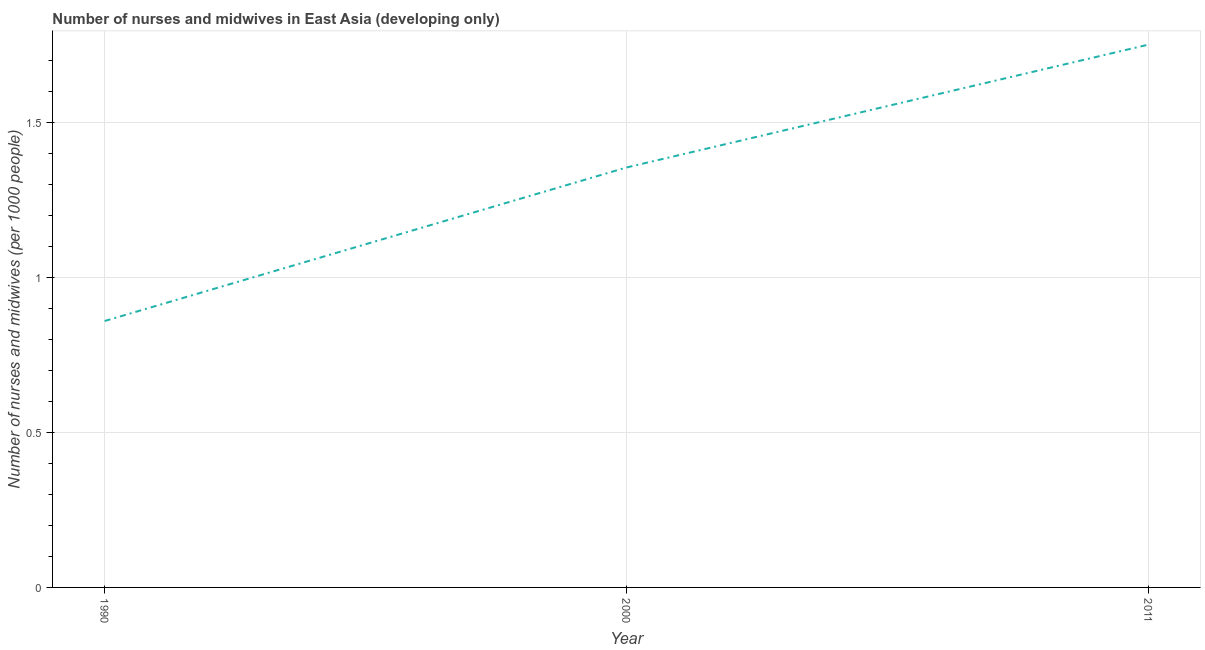What is the number of nurses and midwives in 2011?
Offer a very short reply. 1.75. Across all years, what is the maximum number of nurses and midwives?
Ensure brevity in your answer.  1.75. Across all years, what is the minimum number of nurses and midwives?
Give a very brief answer. 0.86. In which year was the number of nurses and midwives maximum?
Your answer should be compact. 2011. What is the sum of the number of nurses and midwives?
Make the answer very short. 3.97. What is the difference between the number of nurses and midwives in 1990 and 2000?
Give a very brief answer. -0.5. What is the average number of nurses and midwives per year?
Offer a very short reply. 1.32. What is the median number of nurses and midwives?
Offer a very short reply. 1.36. What is the ratio of the number of nurses and midwives in 2000 to that in 2011?
Offer a very short reply. 0.77. Is the number of nurses and midwives in 1990 less than that in 2011?
Provide a succinct answer. Yes. What is the difference between the highest and the second highest number of nurses and midwives?
Your answer should be very brief. 0.4. Is the sum of the number of nurses and midwives in 1990 and 2000 greater than the maximum number of nurses and midwives across all years?
Give a very brief answer. Yes. What is the difference between the highest and the lowest number of nurses and midwives?
Your response must be concise. 0.89. How many lines are there?
Make the answer very short. 1. How many years are there in the graph?
Your answer should be very brief. 3. What is the title of the graph?
Ensure brevity in your answer.  Number of nurses and midwives in East Asia (developing only). What is the label or title of the Y-axis?
Offer a very short reply. Number of nurses and midwives (per 1000 people). What is the Number of nurses and midwives (per 1000 people) in 1990?
Offer a terse response. 0.86. What is the Number of nurses and midwives (per 1000 people) in 2000?
Make the answer very short. 1.36. What is the Number of nurses and midwives (per 1000 people) of 2011?
Provide a succinct answer. 1.75. What is the difference between the Number of nurses and midwives (per 1000 people) in 1990 and 2000?
Your response must be concise. -0.5. What is the difference between the Number of nurses and midwives (per 1000 people) in 1990 and 2011?
Offer a terse response. -0.89. What is the difference between the Number of nurses and midwives (per 1000 people) in 2000 and 2011?
Ensure brevity in your answer.  -0.4. What is the ratio of the Number of nurses and midwives (per 1000 people) in 1990 to that in 2000?
Provide a succinct answer. 0.63. What is the ratio of the Number of nurses and midwives (per 1000 people) in 1990 to that in 2011?
Provide a succinct answer. 0.49. What is the ratio of the Number of nurses and midwives (per 1000 people) in 2000 to that in 2011?
Offer a very short reply. 0.77. 